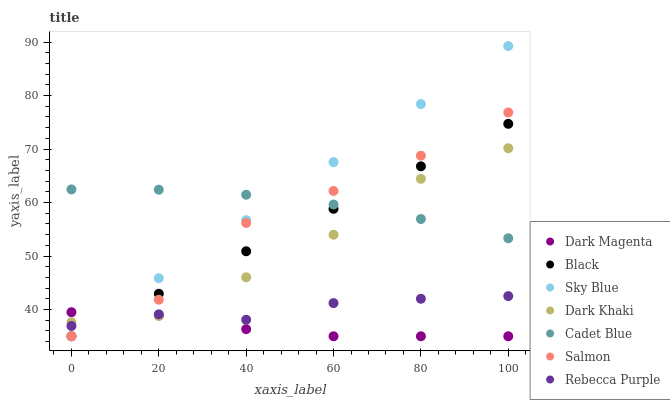Does Dark Magenta have the minimum area under the curve?
Answer yes or no. Yes. Does Sky Blue have the maximum area under the curve?
Answer yes or no. Yes. Does Salmon have the minimum area under the curve?
Answer yes or no. No. Does Salmon have the maximum area under the curve?
Answer yes or no. No. Is Black the smoothest?
Answer yes or no. Yes. Is Salmon the roughest?
Answer yes or no. Yes. Is Dark Magenta the smoothest?
Answer yes or no. No. Is Dark Magenta the roughest?
Answer yes or no. No. Does Dark Magenta have the lowest value?
Answer yes or no. Yes. Does Dark Khaki have the lowest value?
Answer yes or no. No. Does Sky Blue have the highest value?
Answer yes or no. Yes. Does Salmon have the highest value?
Answer yes or no. No. Is Dark Magenta less than Cadet Blue?
Answer yes or no. Yes. Is Cadet Blue greater than Dark Magenta?
Answer yes or no. Yes. Does Dark Khaki intersect Sky Blue?
Answer yes or no. Yes. Is Dark Khaki less than Sky Blue?
Answer yes or no. No. Is Dark Khaki greater than Sky Blue?
Answer yes or no. No. Does Dark Magenta intersect Cadet Blue?
Answer yes or no. No. 